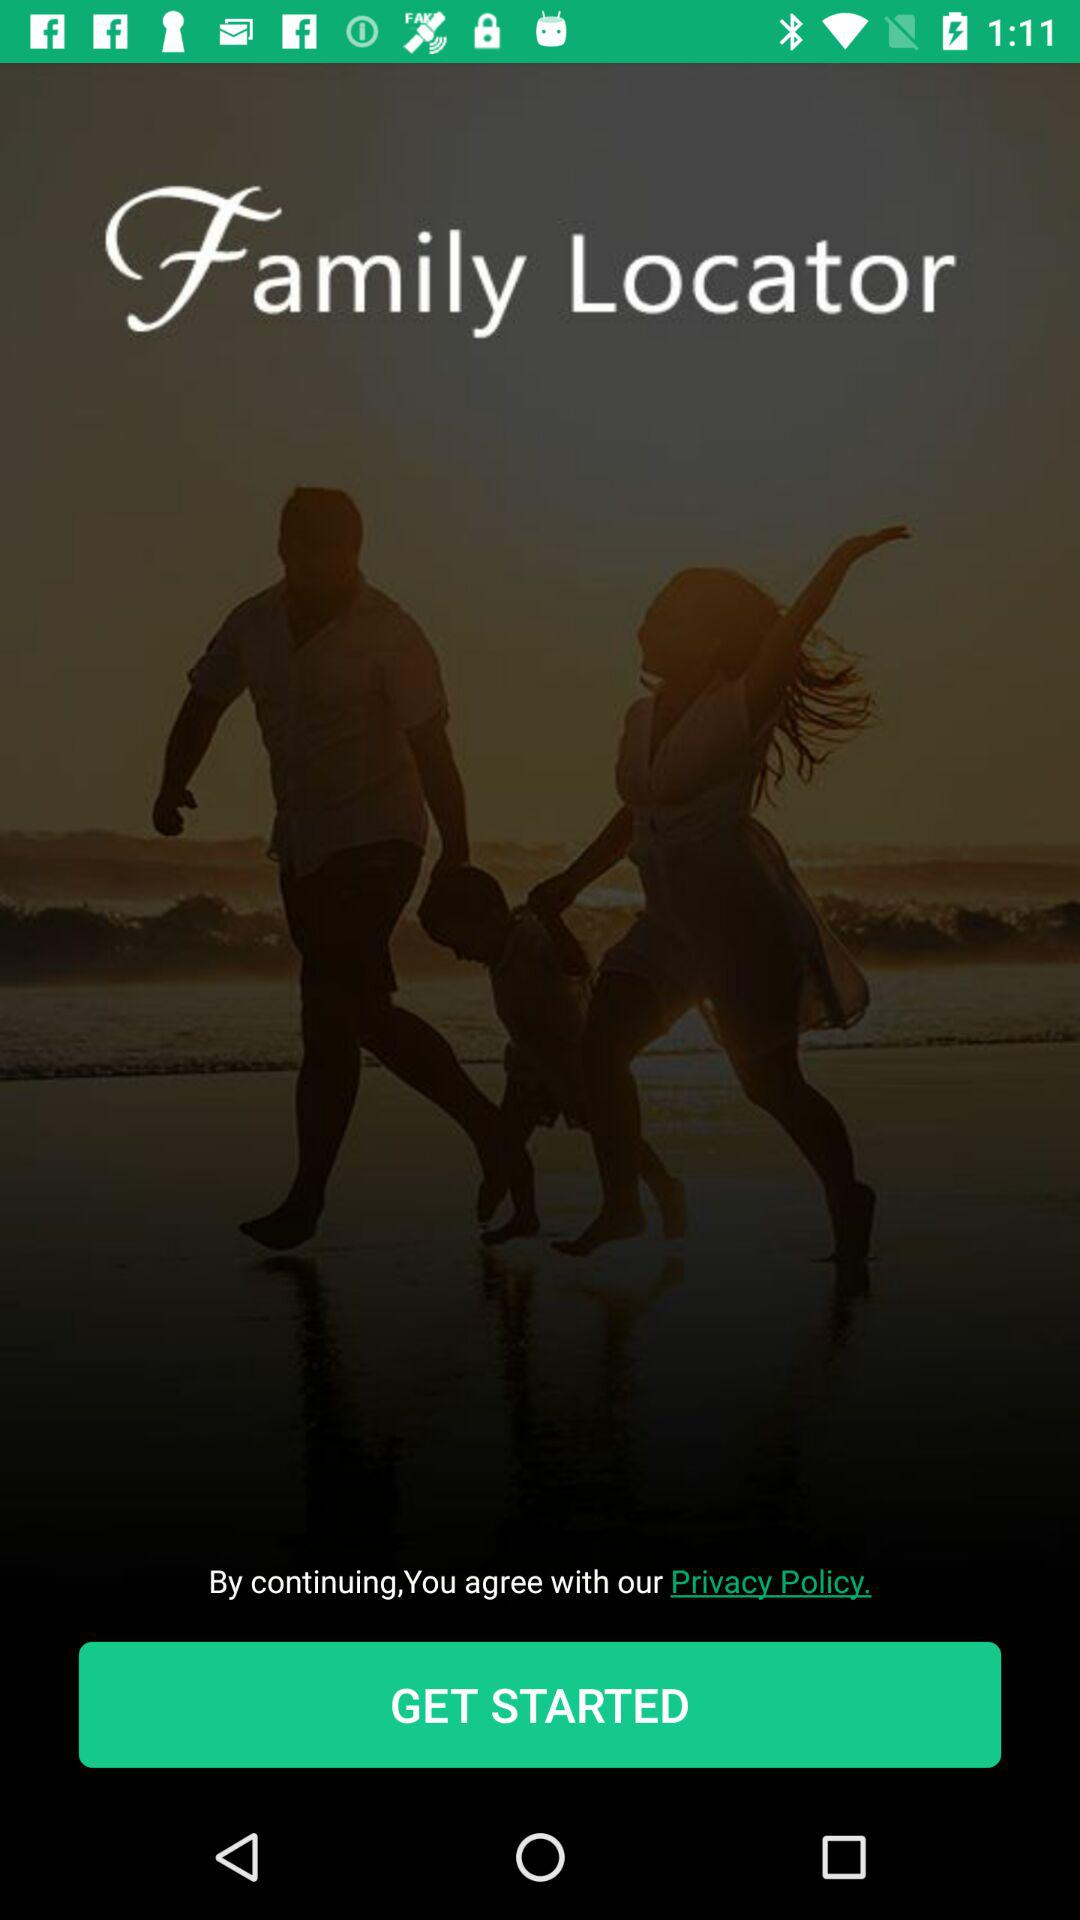What is the application name? The application name is "Family Locator". 